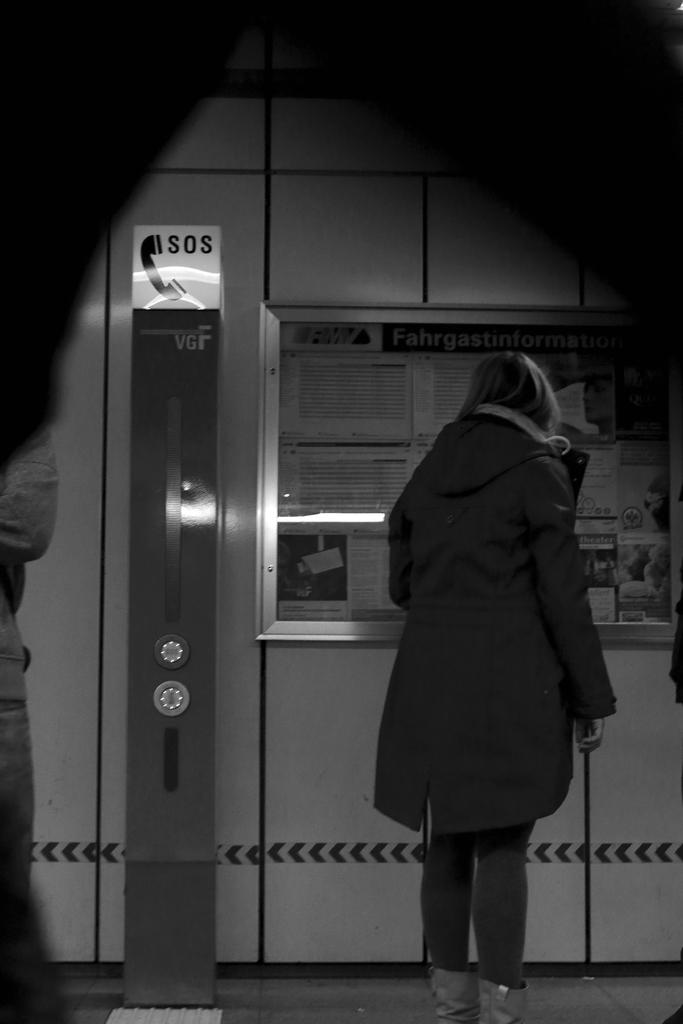Provide a one-sentence caption for the provided image. a woman standing next to a sign that says 'sos'. 